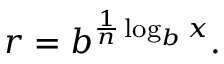<formula> <loc_0><loc_0><loc_500><loc_500>r = b ^ { { \frac { 1 } { n } } \log _ { b } x } .</formula> 